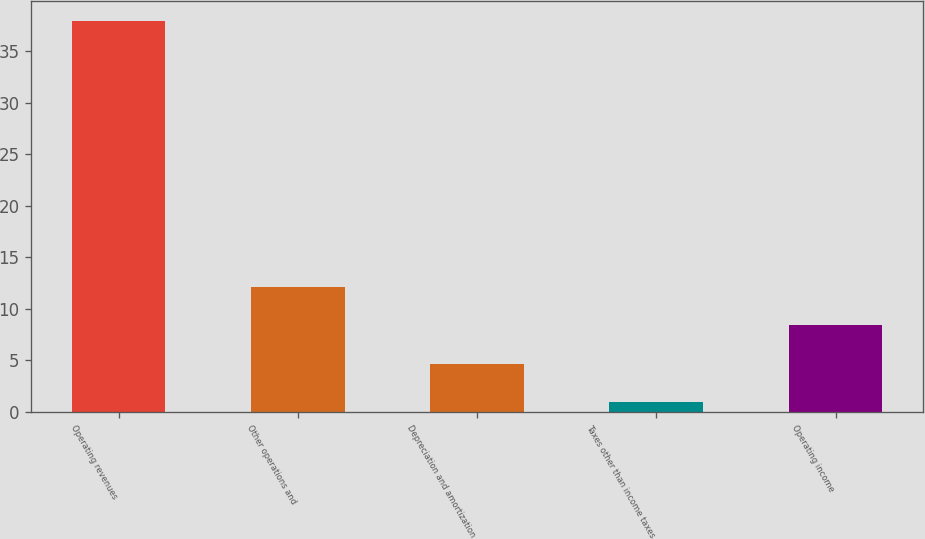Convert chart to OTSL. <chart><loc_0><loc_0><loc_500><loc_500><bar_chart><fcel>Operating revenues<fcel>Other operations and<fcel>Depreciation and amortization<fcel>Taxes other than income taxes<fcel>Operating income<nl><fcel>38<fcel>12.1<fcel>4.7<fcel>1<fcel>8.4<nl></chart> 